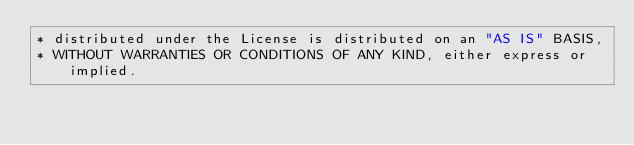<code> <loc_0><loc_0><loc_500><loc_500><_Java_>* distributed under the License is distributed on an "AS IS" BASIS,
* WITHOUT WARRANTIES OR CONDITIONS OF ANY KIND, either express or implied.</code> 